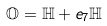<formula> <loc_0><loc_0><loc_500><loc_500>\mathbb { O } = \mathbb { H } + e _ { 7 } \mathbb { H }</formula> 